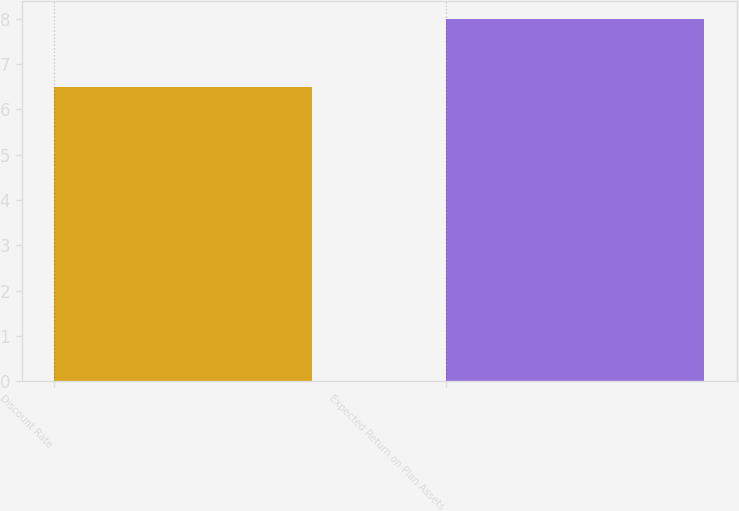Convert chart. <chart><loc_0><loc_0><loc_500><loc_500><bar_chart><fcel>Discount Rate<fcel>Expected Return on Plan Assets<nl><fcel>6.5<fcel>8<nl></chart> 